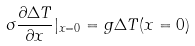Convert formula to latex. <formula><loc_0><loc_0><loc_500><loc_500>\sigma \frac { \partial \Delta T } { \partial x } | _ { x = 0 } = g \Delta T ( x = 0 )</formula> 